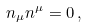Convert formula to latex. <formula><loc_0><loc_0><loc_500><loc_500>n _ { \mu } n ^ { \mu } = 0 \, ,</formula> 